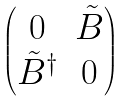Convert formula to latex. <formula><loc_0><loc_0><loc_500><loc_500>\begin{pmatrix} 0 & \tilde { B } \\ \tilde { B } ^ { \dag } & 0 \end{pmatrix}</formula> 